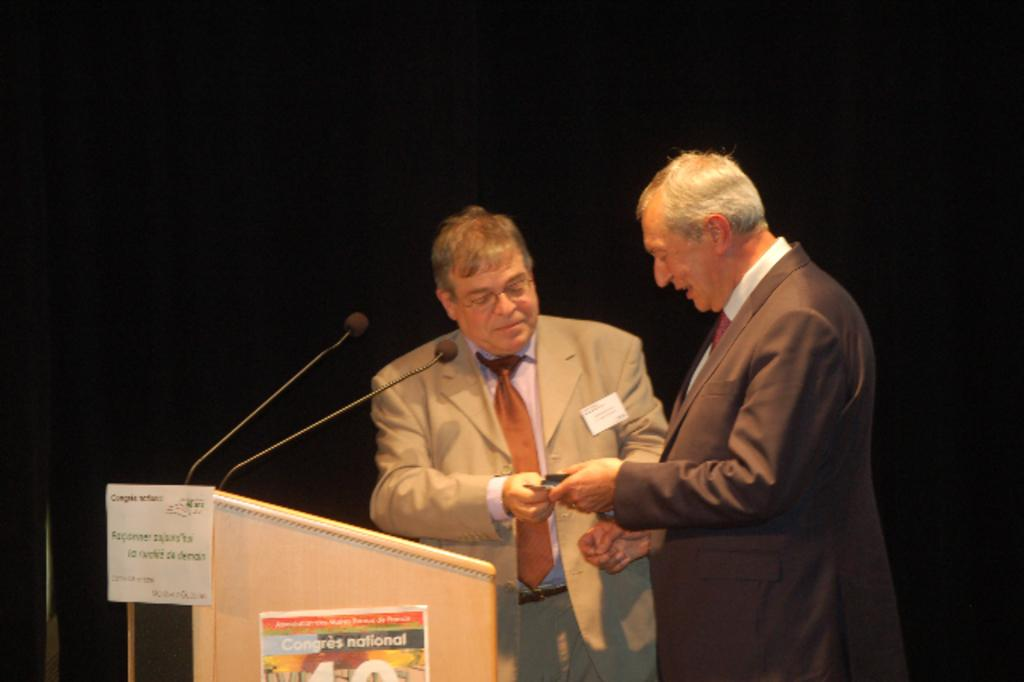What is the main subject of the image? The main subject of the image is men standing near a podium. What can be seen on the podium? There are microphones on the podium. What are the men wearing? The men are wearing formal suits. What are the men holding in their hands? The men are holding papers in their hands. What type of haircut does the man on the left have in the image? There is no information about the men's haircuts in the image, so it cannot be determined. Is the man on the right driving a car in the image? There is no car or driving activity present in the image. 